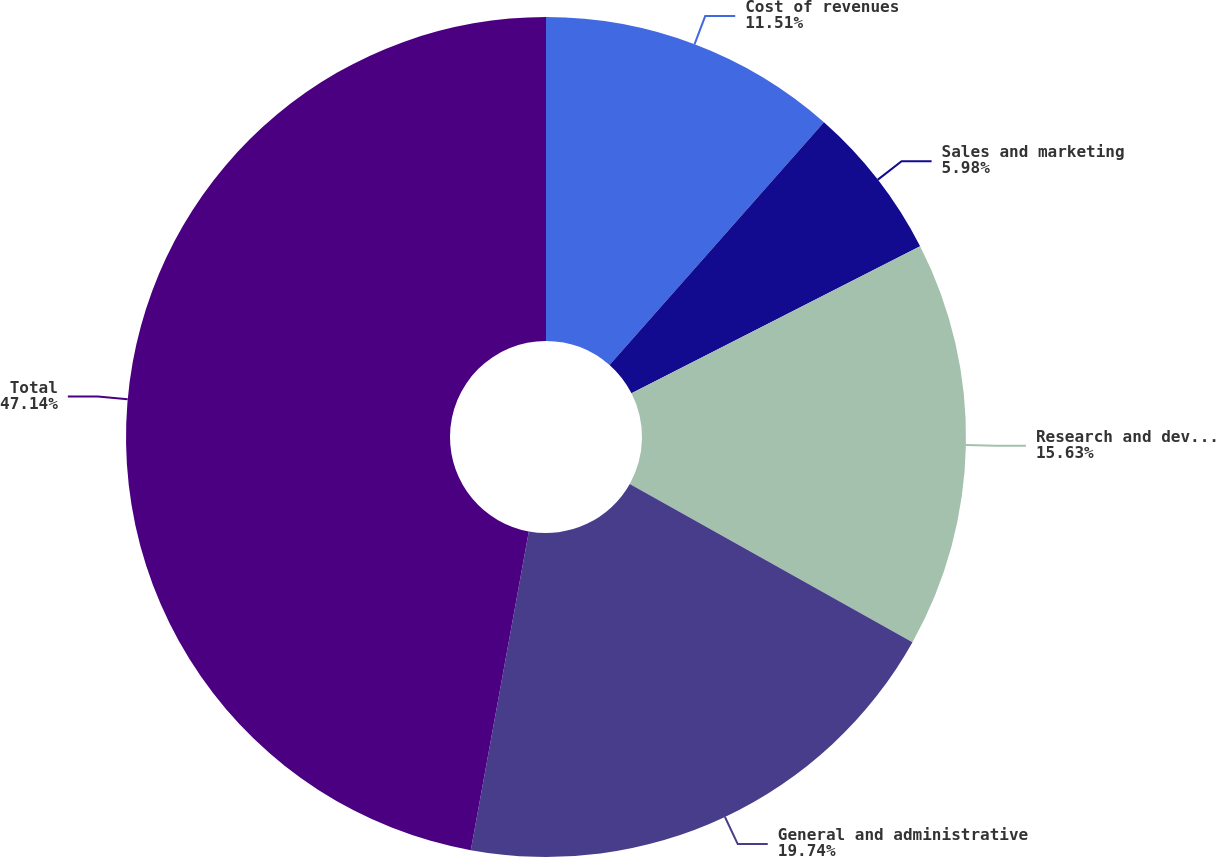Convert chart. <chart><loc_0><loc_0><loc_500><loc_500><pie_chart><fcel>Cost of revenues<fcel>Sales and marketing<fcel>Research and development<fcel>General and administrative<fcel>Total<nl><fcel>11.51%<fcel>5.98%<fcel>15.63%<fcel>19.74%<fcel>47.13%<nl></chart> 